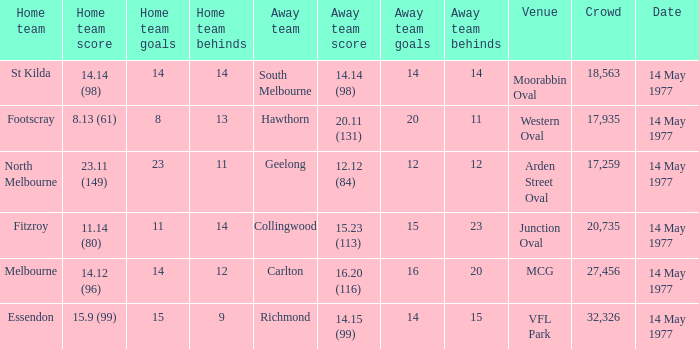How many people were in the crowd with the away team being collingwood? 1.0. 